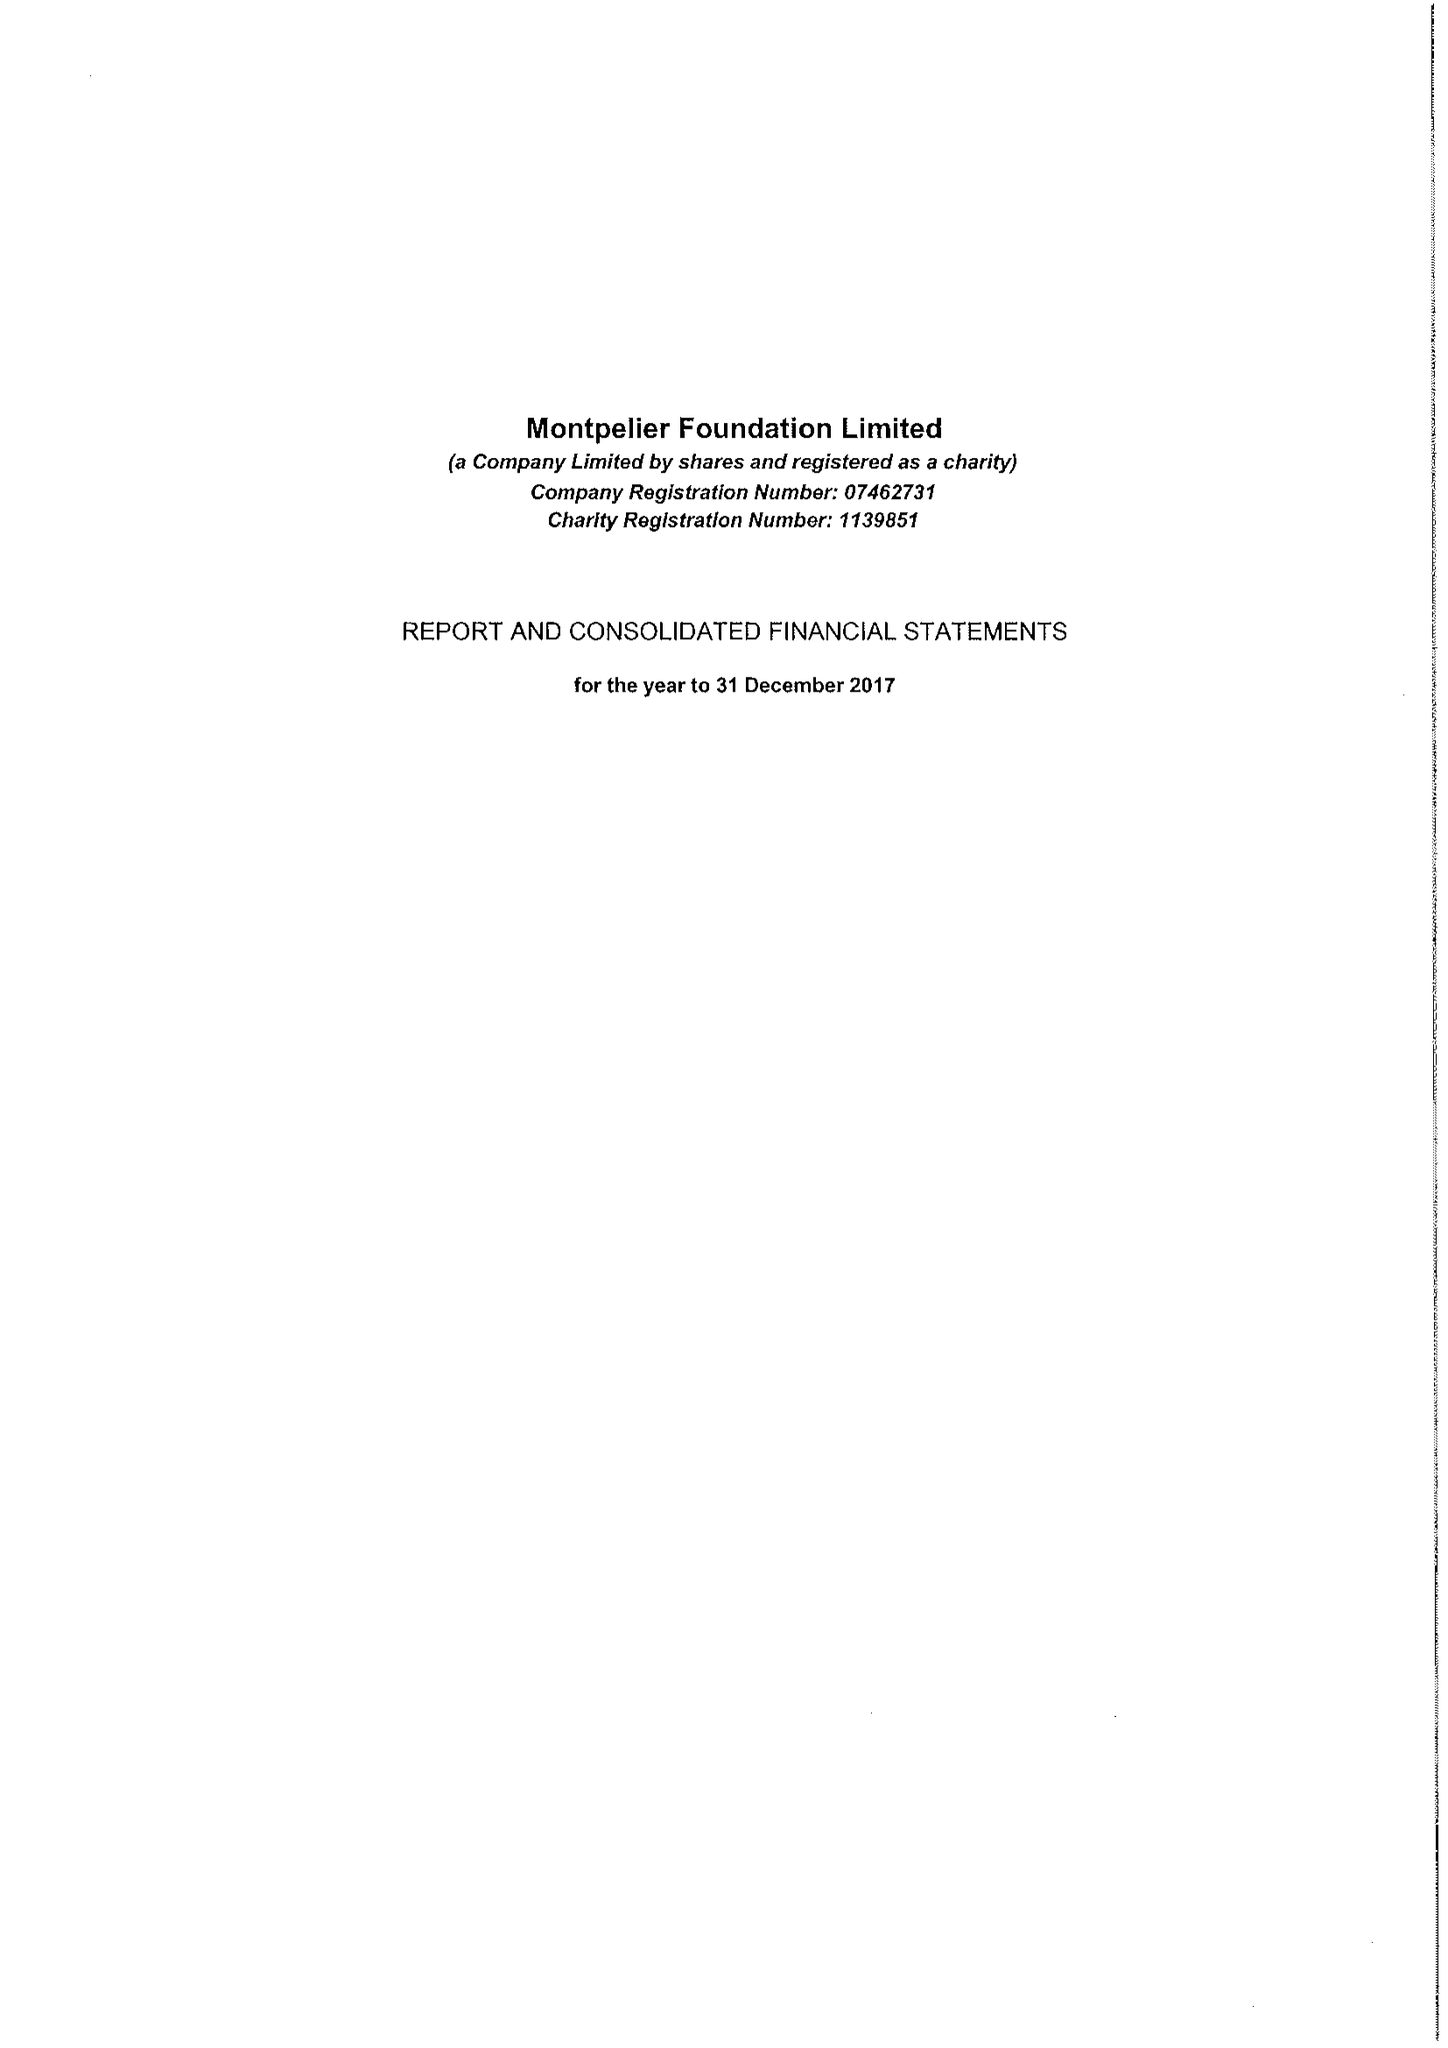What is the value for the charity_name?
Answer the question using a single word or phrase. Montpelier Foundation Ltd. 